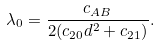<formula> <loc_0><loc_0><loc_500><loc_500>\lambda _ { 0 } = \frac { c _ { A B } } { 2 ( c _ { 2 0 } d ^ { 2 } + c _ { 2 1 } ) } .</formula> 